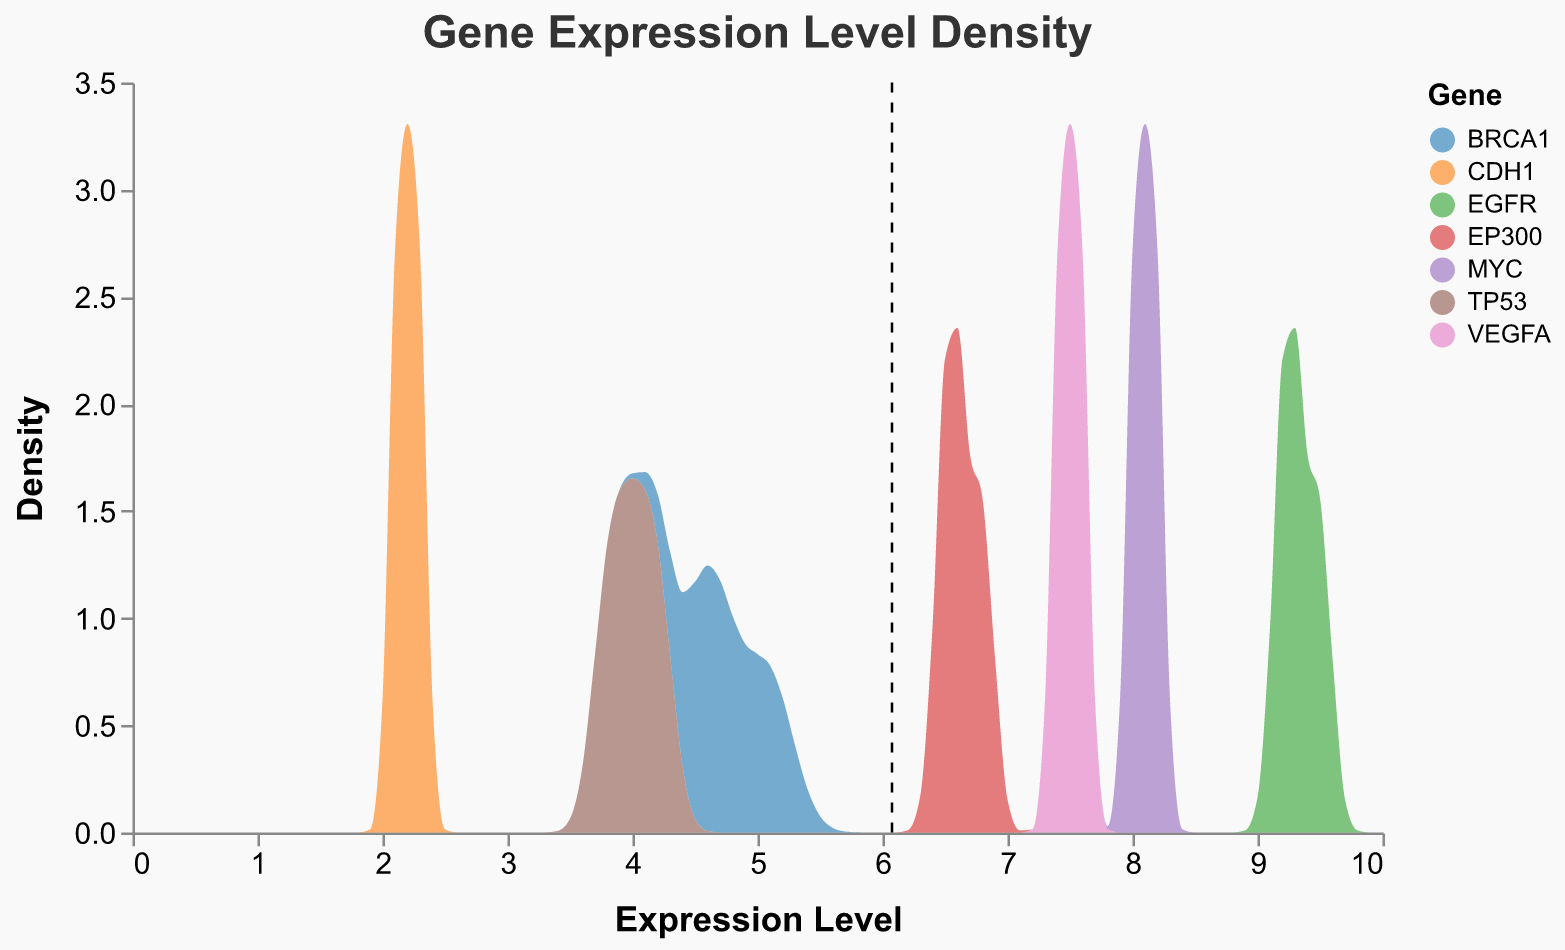What is the title of the figure? The title can be found at the top of the figure, which displays a concise summary of what the plot represents.
Answer: Gene Expression Level Density What is the x-axis representing? The x-axis title indicates the variable being measured, which can be found along the horizontal line of the plot.
Answer: Expression Level What is the gene with the highest mean expression level? Look for the black dashed vertical lines, which indicate the mean expression levels for each gene. The gene with the highest position along the x-axis will have the highest mean expression level.
Answer: EGFR What are the three expression levels shown for BRCA1? The expression levels for each gene are data points in the plot. For BRCA1, these levels are represented as 4.5, 5.1, and 4.7.
Answer: 4.5, 5.1, 4.7 How many genes are represented in the plot? Check the legend on the right side of the plot, which lists all the genes included in the figure.
Answer: 7 Which gene has the densest peak, and what is its approximate density value? Identify the gene with the highest peak in the density plot, and approximate its value from the y-axis.
Answer: MYC, ~2.0 Which gene has the lowest density peak, and what is its approximate density value? Identify the gene with the smallest peak in the density plot, and approximate its value from the y-axis.
Answer: CDH1, ~0.5 What is the mean expression level of TP53? Locate the black dashed vertical line for TP53 and read its value from the x-axis.
Answer: 4.0 Which gene has a mean expression level of approximately 7.5? Find the black dashed vertical line close to 7.5 on the x-axis, and identify the corresponding gene from the legend.
Answer: VEGFA 